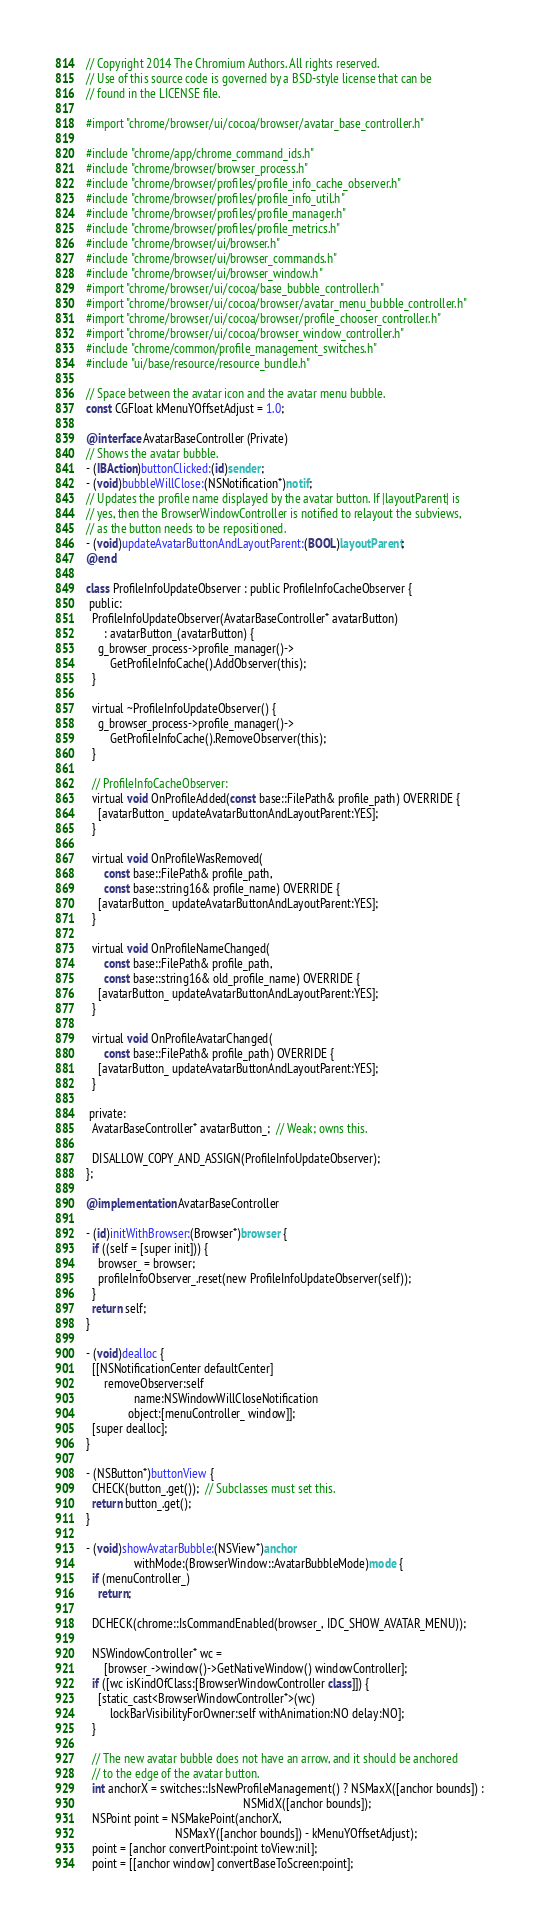<code> <loc_0><loc_0><loc_500><loc_500><_ObjectiveC_>// Copyright 2014 The Chromium Authors. All rights reserved.
// Use of this source code is governed by a BSD-style license that can be
// found in the LICENSE file.

#import "chrome/browser/ui/cocoa/browser/avatar_base_controller.h"

#include "chrome/app/chrome_command_ids.h"
#include "chrome/browser/browser_process.h"
#include "chrome/browser/profiles/profile_info_cache_observer.h"
#include "chrome/browser/profiles/profile_info_util.h"
#include "chrome/browser/profiles/profile_manager.h"
#include "chrome/browser/profiles/profile_metrics.h"
#include "chrome/browser/ui/browser.h"
#include "chrome/browser/ui/browser_commands.h"
#include "chrome/browser/ui/browser_window.h"
#import "chrome/browser/ui/cocoa/base_bubble_controller.h"
#import "chrome/browser/ui/cocoa/browser/avatar_menu_bubble_controller.h"
#import "chrome/browser/ui/cocoa/browser/profile_chooser_controller.h"
#import "chrome/browser/ui/cocoa/browser_window_controller.h"
#include "chrome/common/profile_management_switches.h"
#include "ui/base/resource/resource_bundle.h"

// Space between the avatar icon and the avatar menu bubble.
const CGFloat kMenuYOffsetAdjust = 1.0;

@interface AvatarBaseController (Private)
// Shows the avatar bubble.
- (IBAction)buttonClicked:(id)sender;
- (void)bubbleWillClose:(NSNotification*)notif;
// Updates the profile name displayed by the avatar button. If |layoutParent| is
// yes, then the BrowserWindowController is notified to relayout the subviews,
// as the button needs to be repositioned.
- (void)updateAvatarButtonAndLayoutParent:(BOOL)layoutParent;
@end

class ProfileInfoUpdateObserver : public ProfileInfoCacheObserver {
 public:
  ProfileInfoUpdateObserver(AvatarBaseController* avatarButton)
      : avatarButton_(avatarButton) {
    g_browser_process->profile_manager()->
        GetProfileInfoCache().AddObserver(this);
  }

  virtual ~ProfileInfoUpdateObserver() {
    g_browser_process->profile_manager()->
        GetProfileInfoCache().RemoveObserver(this);
  }

  // ProfileInfoCacheObserver:
  virtual void OnProfileAdded(const base::FilePath& profile_path) OVERRIDE {
    [avatarButton_ updateAvatarButtonAndLayoutParent:YES];
  }

  virtual void OnProfileWasRemoved(
      const base::FilePath& profile_path,
      const base::string16& profile_name) OVERRIDE {
    [avatarButton_ updateAvatarButtonAndLayoutParent:YES];
  }

  virtual void OnProfileNameChanged(
      const base::FilePath& profile_path,
      const base::string16& old_profile_name) OVERRIDE {
    [avatarButton_ updateAvatarButtonAndLayoutParent:YES];
  }

  virtual void OnProfileAvatarChanged(
      const base::FilePath& profile_path) OVERRIDE {
    [avatarButton_ updateAvatarButtonAndLayoutParent:YES];
  }

 private:
  AvatarBaseController* avatarButton_;  // Weak; owns this.

  DISALLOW_COPY_AND_ASSIGN(ProfileInfoUpdateObserver);
};

@implementation AvatarBaseController

- (id)initWithBrowser:(Browser*)browser {
  if ((self = [super init])) {
    browser_ = browser;
    profileInfoObserver_.reset(new ProfileInfoUpdateObserver(self));
  }
  return self;
}

- (void)dealloc {
  [[NSNotificationCenter defaultCenter]
      removeObserver:self
                name:NSWindowWillCloseNotification
              object:[menuController_ window]];
  [super dealloc];
}

- (NSButton*)buttonView {
  CHECK(button_.get());  // Subclasses must set this.
  return button_.get();
}

- (void)showAvatarBubble:(NSView*)anchor
                withMode:(BrowserWindow::AvatarBubbleMode)mode {
  if (menuController_)
    return;

  DCHECK(chrome::IsCommandEnabled(browser_, IDC_SHOW_AVATAR_MENU));

  NSWindowController* wc =
      [browser_->window()->GetNativeWindow() windowController];
  if ([wc isKindOfClass:[BrowserWindowController class]]) {
    [static_cast<BrowserWindowController*>(wc)
        lockBarVisibilityForOwner:self withAnimation:NO delay:NO];
  }

  // The new avatar bubble does not have an arrow, and it should be anchored
  // to the edge of the avatar button.
  int anchorX = switches::IsNewProfileManagement() ? NSMaxX([anchor bounds]) :
                                                     NSMidX([anchor bounds]);
  NSPoint point = NSMakePoint(anchorX,
                              NSMaxY([anchor bounds]) - kMenuYOffsetAdjust);
  point = [anchor convertPoint:point toView:nil];
  point = [[anchor window] convertBaseToScreen:point];
</code> 